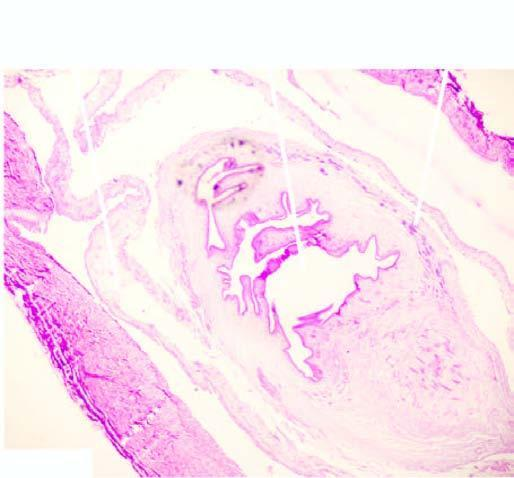s bilayer lipid membrane seen in the cyst while the cyst wall shows palisade layer of histiocytes?
Answer the question using a single word or phrase. No 